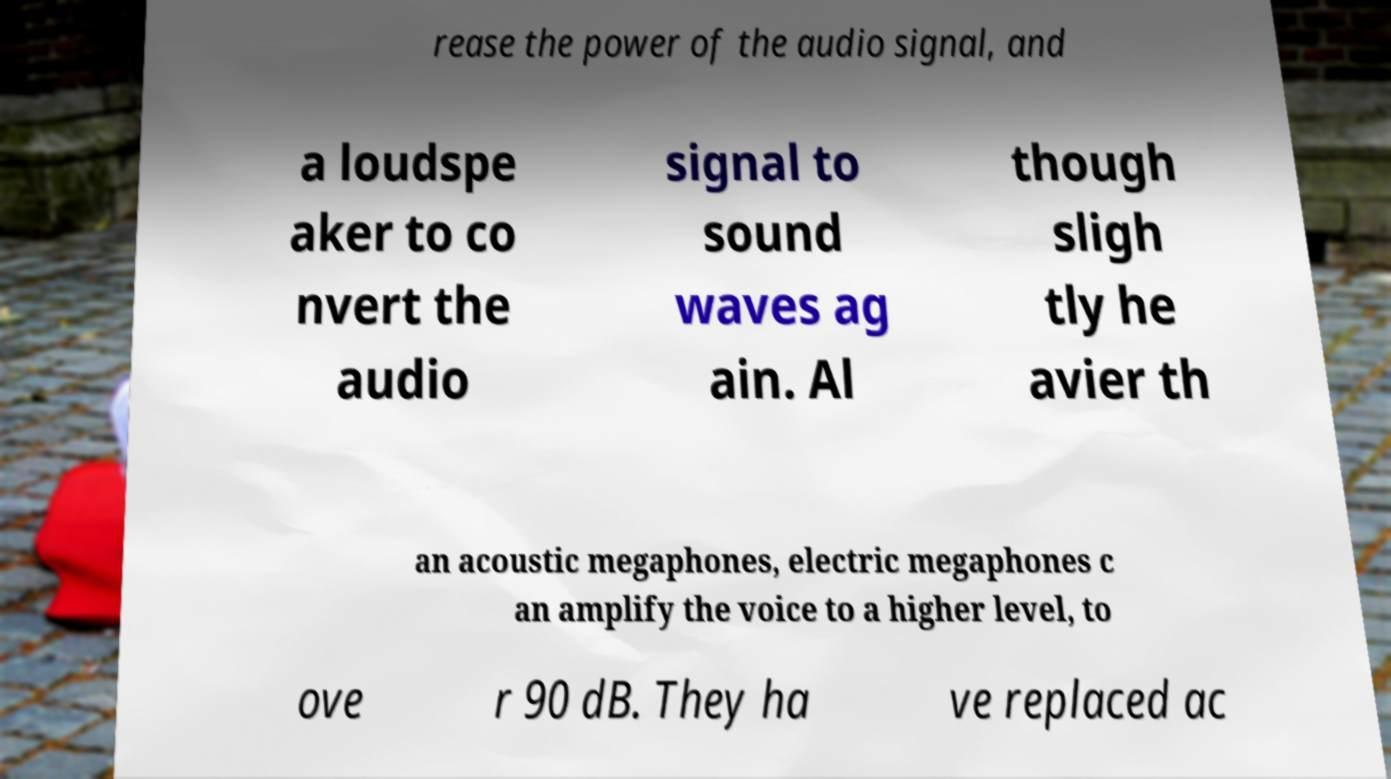Could you extract and type out the text from this image? rease the power of the audio signal, and a loudspe aker to co nvert the audio signal to sound waves ag ain. Al though sligh tly he avier th an acoustic megaphones, electric megaphones c an amplify the voice to a higher level, to ove r 90 dB. They ha ve replaced ac 